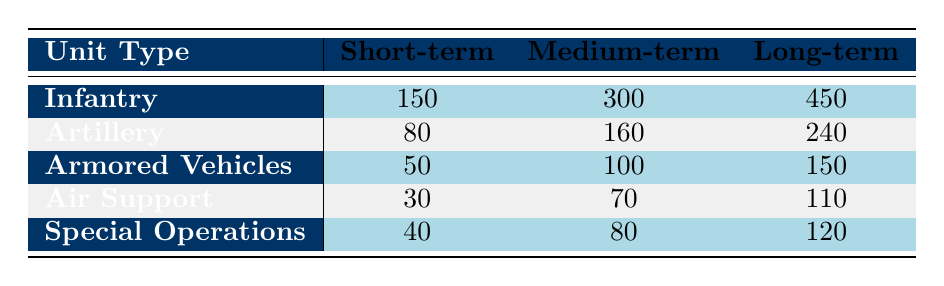What is the total resource allocated to Infantry for all operation durations? To find the total resources allocated to Infantry, I sum the values for each duration: 150 (Short-term) + 300 (Medium-term) + 450 (Long-term) = 900.
Answer: 900 Which unit type received the highest allocation of resources for Long-term operations? Looking at the Long-term allocations, Infantry has 450, Artillery has 240, Armored Vehicles have 150, Air Support has 110, and Special Operations have 120. The maximum value is 450 for Infantry.
Answer: Infantry Is the resource allocation for Air Support greater for Medium-term or Long-term operations? Air Support received 70 for Medium-term and 110 for Long-term. Since 110 is greater than 70, Long-term allocation is higher.
Answer: Long-term What is the average resource allocation for Artillery across all operation durations? The total for Artillery across all durations is 80 (Short-term) + 160 (Medium-term) + 240 (Long-term) = 480, and there are three durations, so the average is 480 / 3 = 160.
Answer: 160 Is it true that Armored Vehicles received less than 100 resources for Long-term operations? The Long-term allocation for Armored Vehicles is 150, which is greater than 100, hence the statement is false.
Answer: False What is the difference in resource allocation between Medium-term and Short-term for Special Operations? For Special Operations, the Medium-term allocation is 80 and the Short-term allocation is 40. The difference is 80 - 40 = 40.
Answer: 40 Which unit type has a resource allocation that doubled from Short-term to Medium-term? Reviewing the data: Infantry goes from 150 to 300 (doubled), Artillery from 80 to 160 (doubled), Armored Vehicles from 50 to 100 (doubled), Air Support from 30 to 70 (not doubled), and Special Operations from 40 to 80 (doubled). Thus, Infantry, Artillery, Armored Vehicles, and Special Operations are all doubled.
Answer: Infantry, Artillery, Armored Vehicles, Special Operations What is the total resource allocation across all unit types for Short-term operations? The total for Short-term is calculated as: 150 (Infantry) + 80 (Artillery) + 50 (Armored Vehicles) + 30 (Air Support) + 40 (Special Operations) = 350.
Answer: 350 